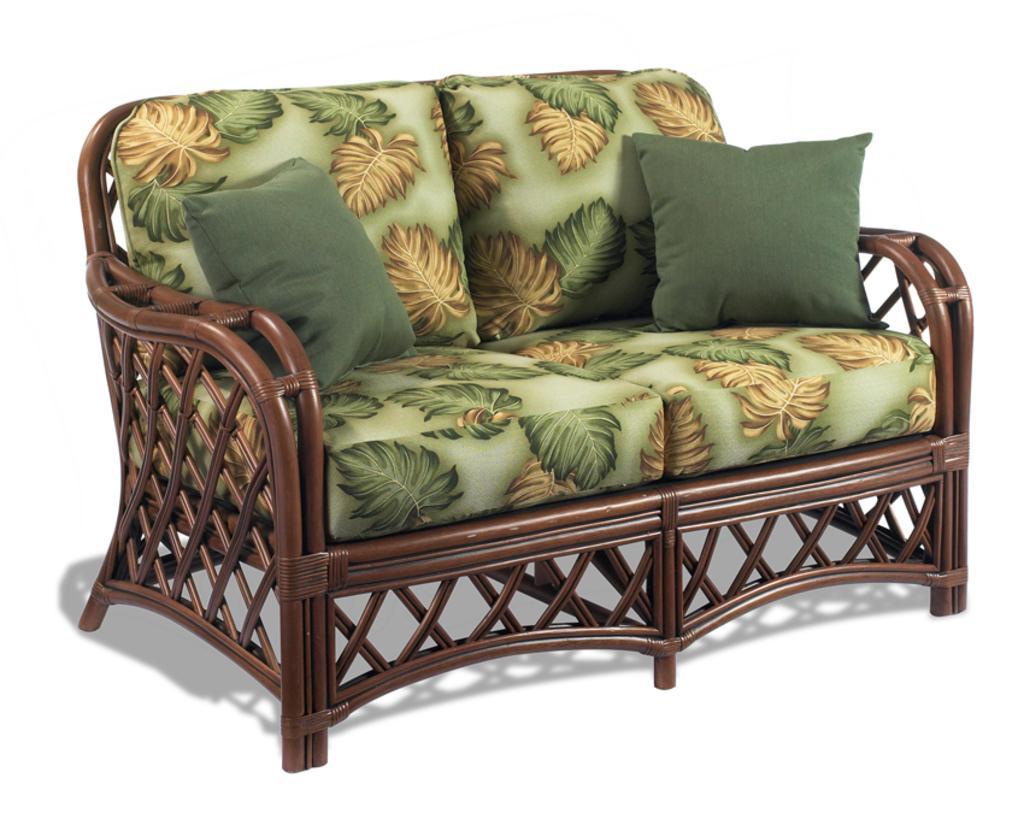How would you summarize this image in a sentence or two? In this picture we can see a couch, there are two pillows on the couch, we can see a white color background. 